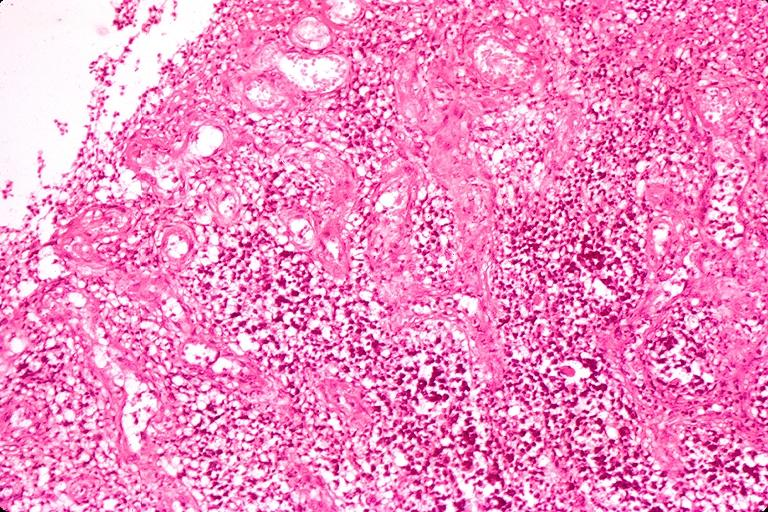s absence of palpebral fissure cleft palate present?
Answer the question using a single word or phrase. No 